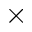Convert formula to latex. <formula><loc_0><loc_0><loc_500><loc_500>\times</formula> 